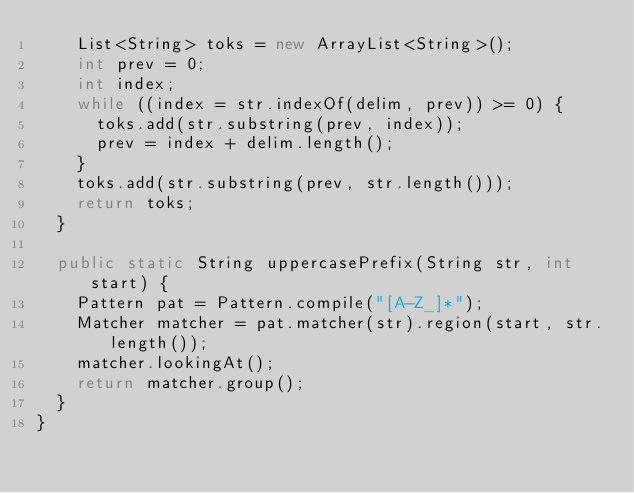Convert code to text. <code><loc_0><loc_0><loc_500><loc_500><_Java_>		List<String> toks = new ArrayList<String>();
		int prev = 0;
		int index;
		while ((index = str.indexOf(delim, prev)) >= 0) {
			toks.add(str.substring(prev, index));
			prev = index + delim.length();
		}
		toks.add(str.substring(prev, str.length()));
		return toks;
	}

	public static String uppercasePrefix(String str, int start) {
		Pattern pat = Pattern.compile("[A-Z_]*");
		Matcher matcher = pat.matcher(str).region(start, str.length());
		matcher.lookingAt();
		return matcher.group();
	}
}
</code> 